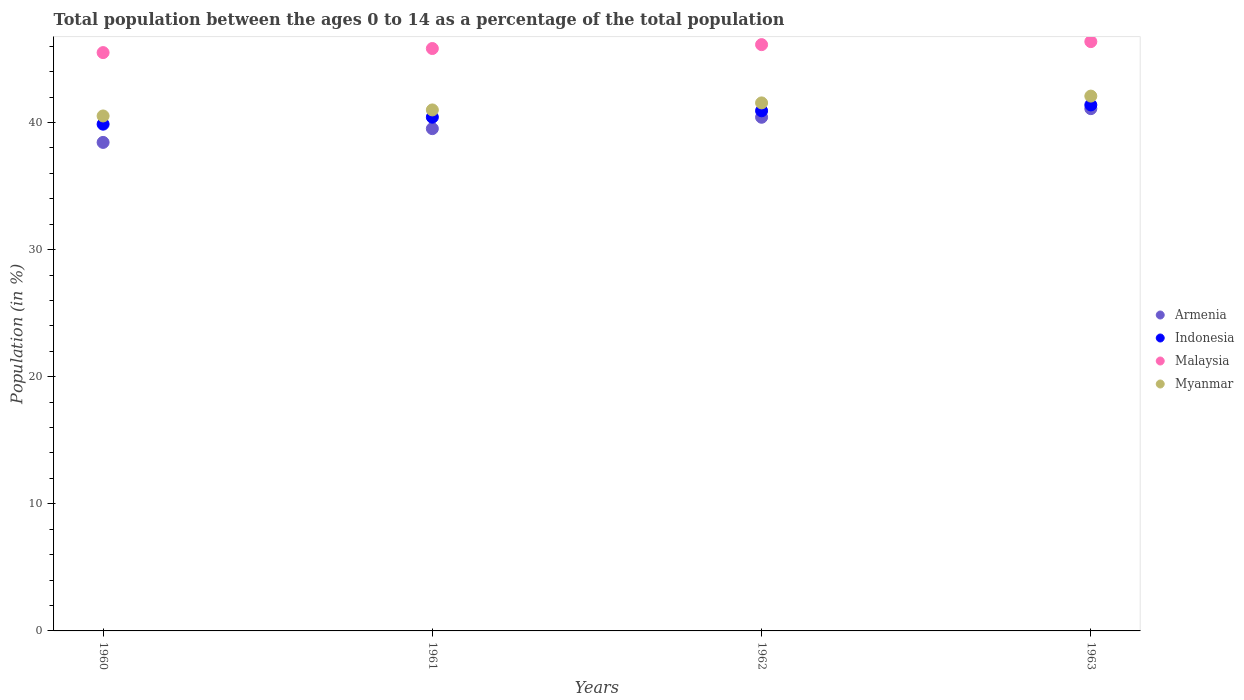Is the number of dotlines equal to the number of legend labels?
Offer a terse response. Yes. What is the percentage of the population ages 0 to 14 in Malaysia in 1960?
Give a very brief answer. 45.5. Across all years, what is the maximum percentage of the population ages 0 to 14 in Indonesia?
Your response must be concise. 41.38. Across all years, what is the minimum percentage of the population ages 0 to 14 in Myanmar?
Provide a short and direct response. 40.52. What is the total percentage of the population ages 0 to 14 in Myanmar in the graph?
Your answer should be compact. 165.12. What is the difference between the percentage of the population ages 0 to 14 in Malaysia in 1960 and that in 1961?
Ensure brevity in your answer.  -0.32. What is the difference between the percentage of the population ages 0 to 14 in Malaysia in 1962 and the percentage of the population ages 0 to 14 in Myanmar in 1961?
Your answer should be very brief. 5.14. What is the average percentage of the population ages 0 to 14 in Myanmar per year?
Provide a succinct answer. 41.28. In the year 1963, what is the difference between the percentage of the population ages 0 to 14 in Malaysia and percentage of the population ages 0 to 14 in Myanmar?
Give a very brief answer. 4.29. What is the ratio of the percentage of the population ages 0 to 14 in Myanmar in 1960 to that in 1961?
Make the answer very short. 0.99. Is the percentage of the population ages 0 to 14 in Malaysia in 1960 less than that in 1961?
Make the answer very short. Yes. What is the difference between the highest and the second highest percentage of the population ages 0 to 14 in Armenia?
Your response must be concise. 0.68. What is the difference between the highest and the lowest percentage of the population ages 0 to 14 in Malaysia?
Provide a short and direct response. 0.86. Does the percentage of the population ages 0 to 14 in Malaysia monotonically increase over the years?
Your response must be concise. Yes. Is the percentage of the population ages 0 to 14 in Malaysia strictly greater than the percentage of the population ages 0 to 14 in Armenia over the years?
Ensure brevity in your answer.  Yes. What is the difference between two consecutive major ticks on the Y-axis?
Provide a succinct answer. 10. Does the graph contain grids?
Give a very brief answer. No. How many legend labels are there?
Your answer should be compact. 4. What is the title of the graph?
Your response must be concise. Total population between the ages 0 to 14 as a percentage of the total population. What is the label or title of the X-axis?
Offer a very short reply. Years. What is the Population (in %) in Armenia in 1960?
Offer a very short reply. 38.43. What is the Population (in %) of Indonesia in 1960?
Your response must be concise. 39.87. What is the Population (in %) in Malaysia in 1960?
Offer a very short reply. 45.5. What is the Population (in %) of Myanmar in 1960?
Keep it short and to the point. 40.52. What is the Population (in %) in Armenia in 1961?
Ensure brevity in your answer.  39.52. What is the Population (in %) in Indonesia in 1961?
Provide a short and direct response. 40.42. What is the Population (in %) in Malaysia in 1961?
Ensure brevity in your answer.  45.82. What is the Population (in %) in Myanmar in 1961?
Your answer should be very brief. 40.99. What is the Population (in %) of Armenia in 1962?
Keep it short and to the point. 40.41. What is the Population (in %) in Indonesia in 1962?
Your answer should be compact. 40.92. What is the Population (in %) of Malaysia in 1962?
Your answer should be very brief. 46.13. What is the Population (in %) in Myanmar in 1962?
Ensure brevity in your answer.  41.54. What is the Population (in %) of Armenia in 1963?
Provide a short and direct response. 41.09. What is the Population (in %) of Indonesia in 1963?
Make the answer very short. 41.38. What is the Population (in %) in Malaysia in 1963?
Your answer should be compact. 46.36. What is the Population (in %) of Myanmar in 1963?
Your answer should be compact. 42.08. Across all years, what is the maximum Population (in %) of Armenia?
Offer a very short reply. 41.09. Across all years, what is the maximum Population (in %) in Indonesia?
Provide a short and direct response. 41.38. Across all years, what is the maximum Population (in %) of Malaysia?
Your answer should be compact. 46.36. Across all years, what is the maximum Population (in %) of Myanmar?
Offer a very short reply. 42.08. Across all years, what is the minimum Population (in %) in Armenia?
Ensure brevity in your answer.  38.43. Across all years, what is the minimum Population (in %) of Indonesia?
Your answer should be compact. 39.87. Across all years, what is the minimum Population (in %) of Malaysia?
Your answer should be very brief. 45.5. Across all years, what is the minimum Population (in %) in Myanmar?
Offer a terse response. 40.52. What is the total Population (in %) in Armenia in the graph?
Provide a succinct answer. 159.45. What is the total Population (in %) in Indonesia in the graph?
Offer a very short reply. 162.59. What is the total Population (in %) in Malaysia in the graph?
Your response must be concise. 183.81. What is the total Population (in %) of Myanmar in the graph?
Give a very brief answer. 165.12. What is the difference between the Population (in %) in Armenia in 1960 and that in 1961?
Your answer should be very brief. -1.08. What is the difference between the Population (in %) in Indonesia in 1960 and that in 1961?
Provide a succinct answer. -0.55. What is the difference between the Population (in %) in Malaysia in 1960 and that in 1961?
Provide a short and direct response. -0.32. What is the difference between the Population (in %) of Myanmar in 1960 and that in 1961?
Ensure brevity in your answer.  -0.47. What is the difference between the Population (in %) of Armenia in 1960 and that in 1962?
Make the answer very short. -1.98. What is the difference between the Population (in %) in Indonesia in 1960 and that in 1962?
Offer a very short reply. -1.05. What is the difference between the Population (in %) of Malaysia in 1960 and that in 1962?
Give a very brief answer. -0.63. What is the difference between the Population (in %) of Myanmar in 1960 and that in 1962?
Keep it short and to the point. -1.03. What is the difference between the Population (in %) in Armenia in 1960 and that in 1963?
Give a very brief answer. -2.66. What is the difference between the Population (in %) in Indonesia in 1960 and that in 1963?
Your answer should be compact. -1.51. What is the difference between the Population (in %) of Malaysia in 1960 and that in 1963?
Your response must be concise. -0.86. What is the difference between the Population (in %) in Myanmar in 1960 and that in 1963?
Provide a succinct answer. -1.56. What is the difference between the Population (in %) in Armenia in 1961 and that in 1962?
Offer a terse response. -0.89. What is the difference between the Population (in %) of Indonesia in 1961 and that in 1962?
Ensure brevity in your answer.  -0.5. What is the difference between the Population (in %) of Malaysia in 1961 and that in 1962?
Offer a terse response. -0.31. What is the difference between the Population (in %) in Myanmar in 1961 and that in 1962?
Your answer should be compact. -0.55. What is the difference between the Population (in %) of Armenia in 1961 and that in 1963?
Provide a short and direct response. -1.57. What is the difference between the Population (in %) in Indonesia in 1961 and that in 1963?
Your response must be concise. -0.96. What is the difference between the Population (in %) of Malaysia in 1961 and that in 1963?
Your answer should be very brief. -0.54. What is the difference between the Population (in %) of Myanmar in 1961 and that in 1963?
Keep it short and to the point. -1.09. What is the difference between the Population (in %) in Armenia in 1962 and that in 1963?
Provide a short and direct response. -0.68. What is the difference between the Population (in %) in Indonesia in 1962 and that in 1963?
Offer a terse response. -0.46. What is the difference between the Population (in %) in Malaysia in 1962 and that in 1963?
Your answer should be very brief. -0.24. What is the difference between the Population (in %) in Myanmar in 1962 and that in 1963?
Your answer should be very brief. -0.54. What is the difference between the Population (in %) in Armenia in 1960 and the Population (in %) in Indonesia in 1961?
Keep it short and to the point. -1.98. What is the difference between the Population (in %) of Armenia in 1960 and the Population (in %) of Malaysia in 1961?
Provide a short and direct response. -7.39. What is the difference between the Population (in %) of Armenia in 1960 and the Population (in %) of Myanmar in 1961?
Offer a very short reply. -2.56. What is the difference between the Population (in %) in Indonesia in 1960 and the Population (in %) in Malaysia in 1961?
Make the answer very short. -5.95. What is the difference between the Population (in %) of Indonesia in 1960 and the Population (in %) of Myanmar in 1961?
Keep it short and to the point. -1.12. What is the difference between the Population (in %) of Malaysia in 1960 and the Population (in %) of Myanmar in 1961?
Make the answer very short. 4.51. What is the difference between the Population (in %) in Armenia in 1960 and the Population (in %) in Indonesia in 1962?
Provide a short and direct response. -2.49. What is the difference between the Population (in %) in Armenia in 1960 and the Population (in %) in Malaysia in 1962?
Provide a short and direct response. -7.69. What is the difference between the Population (in %) in Armenia in 1960 and the Population (in %) in Myanmar in 1962?
Your answer should be compact. -3.11. What is the difference between the Population (in %) in Indonesia in 1960 and the Population (in %) in Malaysia in 1962?
Give a very brief answer. -6.26. What is the difference between the Population (in %) in Indonesia in 1960 and the Population (in %) in Myanmar in 1962?
Your answer should be very brief. -1.67. What is the difference between the Population (in %) in Malaysia in 1960 and the Population (in %) in Myanmar in 1962?
Make the answer very short. 3.96. What is the difference between the Population (in %) in Armenia in 1960 and the Population (in %) in Indonesia in 1963?
Keep it short and to the point. -2.95. What is the difference between the Population (in %) of Armenia in 1960 and the Population (in %) of Malaysia in 1963?
Keep it short and to the point. -7.93. What is the difference between the Population (in %) in Armenia in 1960 and the Population (in %) in Myanmar in 1963?
Offer a very short reply. -3.64. What is the difference between the Population (in %) of Indonesia in 1960 and the Population (in %) of Malaysia in 1963?
Offer a terse response. -6.49. What is the difference between the Population (in %) of Indonesia in 1960 and the Population (in %) of Myanmar in 1963?
Your response must be concise. -2.21. What is the difference between the Population (in %) in Malaysia in 1960 and the Population (in %) in Myanmar in 1963?
Keep it short and to the point. 3.42. What is the difference between the Population (in %) of Armenia in 1961 and the Population (in %) of Indonesia in 1962?
Provide a succinct answer. -1.4. What is the difference between the Population (in %) in Armenia in 1961 and the Population (in %) in Malaysia in 1962?
Make the answer very short. -6.61. What is the difference between the Population (in %) in Armenia in 1961 and the Population (in %) in Myanmar in 1962?
Ensure brevity in your answer.  -2.02. What is the difference between the Population (in %) of Indonesia in 1961 and the Population (in %) of Malaysia in 1962?
Your response must be concise. -5.71. What is the difference between the Population (in %) in Indonesia in 1961 and the Population (in %) in Myanmar in 1962?
Give a very brief answer. -1.12. What is the difference between the Population (in %) in Malaysia in 1961 and the Population (in %) in Myanmar in 1962?
Offer a terse response. 4.28. What is the difference between the Population (in %) in Armenia in 1961 and the Population (in %) in Indonesia in 1963?
Provide a short and direct response. -1.87. What is the difference between the Population (in %) of Armenia in 1961 and the Population (in %) of Malaysia in 1963?
Keep it short and to the point. -6.85. What is the difference between the Population (in %) in Armenia in 1961 and the Population (in %) in Myanmar in 1963?
Your answer should be very brief. -2.56. What is the difference between the Population (in %) in Indonesia in 1961 and the Population (in %) in Malaysia in 1963?
Make the answer very short. -5.95. What is the difference between the Population (in %) of Indonesia in 1961 and the Population (in %) of Myanmar in 1963?
Offer a terse response. -1.66. What is the difference between the Population (in %) of Malaysia in 1961 and the Population (in %) of Myanmar in 1963?
Your response must be concise. 3.74. What is the difference between the Population (in %) in Armenia in 1962 and the Population (in %) in Indonesia in 1963?
Ensure brevity in your answer.  -0.97. What is the difference between the Population (in %) in Armenia in 1962 and the Population (in %) in Malaysia in 1963?
Offer a terse response. -5.95. What is the difference between the Population (in %) in Armenia in 1962 and the Population (in %) in Myanmar in 1963?
Give a very brief answer. -1.67. What is the difference between the Population (in %) of Indonesia in 1962 and the Population (in %) of Malaysia in 1963?
Your answer should be compact. -5.44. What is the difference between the Population (in %) of Indonesia in 1962 and the Population (in %) of Myanmar in 1963?
Make the answer very short. -1.16. What is the difference between the Population (in %) of Malaysia in 1962 and the Population (in %) of Myanmar in 1963?
Make the answer very short. 4.05. What is the average Population (in %) of Armenia per year?
Your response must be concise. 39.86. What is the average Population (in %) in Indonesia per year?
Ensure brevity in your answer.  40.65. What is the average Population (in %) in Malaysia per year?
Offer a very short reply. 45.95. What is the average Population (in %) of Myanmar per year?
Provide a succinct answer. 41.28. In the year 1960, what is the difference between the Population (in %) in Armenia and Population (in %) in Indonesia?
Offer a terse response. -1.44. In the year 1960, what is the difference between the Population (in %) of Armenia and Population (in %) of Malaysia?
Keep it short and to the point. -7.07. In the year 1960, what is the difference between the Population (in %) in Armenia and Population (in %) in Myanmar?
Provide a short and direct response. -2.08. In the year 1960, what is the difference between the Population (in %) in Indonesia and Population (in %) in Malaysia?
Offer a terse response. -5.63. In the year 1960, what is the difference between the Population (in %) of Indonesia and Population (in %) of Myanmar?
Your response must be concise. -0.65. In the year 1960, what is the difference between the Population (in %) in Malaysia and Population (in %) in Myanmar?
Ensure brevity in your answer.  4.98. In the year 1961, what is the difference between the Population (in %) of Armenia and Population (in %) of Indonesia?
Offer a very short reply. -0.9. In the year 1961, what is the difference between the Population (in %) in Armenia and Population (in %) in Malaysia?
Ensure brevity in your answer.  -6.3. In the year 1961, what is the difference between the Population (in %) in Armenia and Population (in %) in Myanmar?
Your response must be concise. -1.47. In the year 1961, what is the difference between the Population (in %) in Indonesia and Population (in %) in Malaysia?
Offer a terse response. -5.4. In the year 1961, what is the difference between the Population (in %) in Indonesia and Population (in %) in Myanmar?
Your answer should be very brief. -0.57. In the year 1961, what is the difference between the Population (in %) of Malaysia and Population (in %) of Myanmar?
Offer a very short reply. 4.83. In the year 1962, what is the difference between the Population (in %) of Armenia and Population (in %) of Indonesia?
Your response must be concise. -0.51. In the year 1962, what is the difference between the Population (in %) in Armenia and Population (in %) in Malaysia?
Offer a very short reply. -5.71. In the year 1962, what is the difference between the Population (in %) in Armenia and Population (in %) in Myanmar?
Your response must be concise. -1.13. In the year 1962, what is the difference between the Population (in %) of Indonesia and Population (in %) of Malaysia?
Your response must be concise. -5.21. In the year 1962, what is the difference between the Population (in %) in Indonesia and Population (in %) in Myanmar?
Give a very brief answer. -0.62. In the year 1962, what is the difference between the Population (in %) in Malaysia and Population (in %) in Myanmar?
Make the answer very short. 4.58. In the year 1963, what is the difference between the Population (in %) in Armenia and Population (in %) in Indonesia?
Your answer should be compact. -0.29. In the year 1963, what is the difference between the Population (in %) in Armenia and Population (in %) in Malaysia?
Ensure brevity in your answer.  -5.27. In the year 1963, what is the difference between the Population (in %) of Armenia and Population (in %) of Myanmar?
Provide a short and direct response. -0.99. In the year 1963, what is the difference between the Population (in %) of Indonesia and Population (in %) of Malaysia?
Make the answer very short. -4.98. In the year 1963, what is the difference between the Population (in %) in Indonesia and Population (in %) in Myanmar?
Your answer should be compact. -0.7. In the year 1963, what is the difference between the Population (in %) in Malaysia and Population (in %) in Myanmar?
Keep it short and to the point. 4.29. What is the ratio of the Population (in %) in Armenia in 1960 to that in 1961?
Your answer should be compact. 0.97. What is the ratio of the Population (in %) of Indonesia in 1960 to that in 1961?
Your response must be concise. 0.99. What is the ratio of the Population (in %) of Malaysia in 1960 to that in 1961?
Provide a short and direct response. 0.99. What is the ratio of the Population (in %) in Myanmar in 1960 to that in 1961?
Your response must be concise. 0.99. What is the ratio of the Population (in %) of Armenia in 1960 to that in 1962?
Provide a short and direct response. 0.95. What is the ratio of the Population (in %) of Indonesia in 1960 to that in 1962?
Offer a terse response. 0.97. What is the ratio of the Population (in %) in Malaysia in 1960 to that in 1962?
Give a very brief answer. 0.99. What is the ratio of the Population (in %) in Myanmar in 1960 to that in 1962?
Ensure brevity in your answer.  0.98. What is the ratio of the Population (in %) of Armenia in 1960 to that in 1963?
Make the answer very short. 0.94. What is the ratio of the Population (in %) in Indonesia in 1960 to that in 1963?
Provide a short and direct response. 0.96. What is the ratio of the Population (in %) of Malaysia in 1960 to that in 1963?
Provide a short and direct response. 0.98. What is the ratio of the Population (in %) in Myanmar in 1960 to that in 1963?
Provide a succinct answer. 0.96. What is the ratio of the Population (in %) of Armenia in 1961 to that in 1962?
Offer a very short reply. 0.98. What is the ratio of the Population (in %) of Indonesia in 1961 to that in 1962?
Provide a succinct answer. 0.99. What is the ratio of the Population (in %) of Myanmar in 1961 to that in 1962?
Offer a very short reply. 0.99. What is the ratio of the Population (in %) in Armenia in 1961 to that in 1963?
Provide a short and direct response. 0.96. What is the ratio of the Population (in %) of Indonesia in 1961 to that in 1963?
Offer a very short reply. 0.98. What is the ratio of the Population (in %) of Malaysia in 1961 to that in 1963?
Offer a terse response. 0.99. What is the ratio of the Population (in %) in Myanmar in 1961 to that in 1963?
Give a very brief answer. 0.97. What is the ratio of the Population (in %) of Armenia in 1962 to that in 1963?
Make the answer very short. 0.98. What is the ratio of the Population (in %) in Indonesia in 1962 to that in 1963?
Offer a terse response. 0.99. What is the ratio of the Population (in %) in Malaysia in 1962 to that in 1963?
Give a very brief answer. 0.99. What is the ratio of the Population (in %) in Myanmar in 1962 to that in 1963?
Your answer should be compact. 0.99. What is the difference between the highest and the second highest Population (in %) of Armenia?
Provide a succinct answer. 0.68. What is the difference between the highest and the second highest Population (in %) of Indonesia?
Provide a short and direct response. 0.46. What is the difference between the highest and the second highest Population (in %) of Malaysia?
Offer a very short reply. 0.24. What is the difference between the highest and the second highest Population (in %) of Myanmar?
Your answer should be very brief. 0.54. What is the difference between the highest and the lowest Population (in %) of Armenia?
Your answer should be compact. 2.66. What is the difference between the highest and the lowest Population (in %) of Indonesia?
Offer a terse response. 1.51. What is the difference between the highest and the lowest Population (in %) in Malaysia?
Provide a short and direct response. 0.86. What is the difference between the highest and the lowest Population (in %) of Myanmar?
Keep it short and to the point. 1.56. 